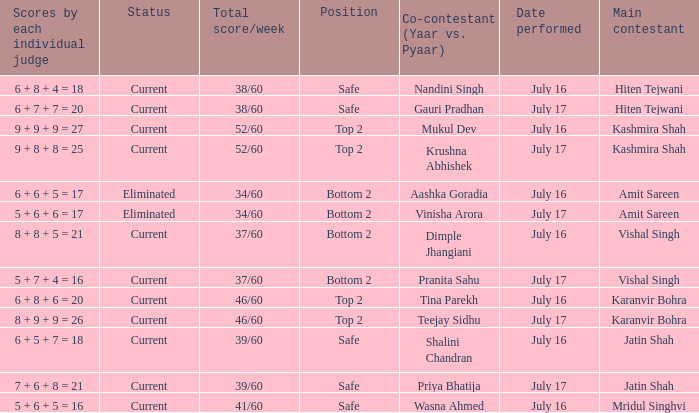What position did Pranita Sahu's team get? Bottom 2. 